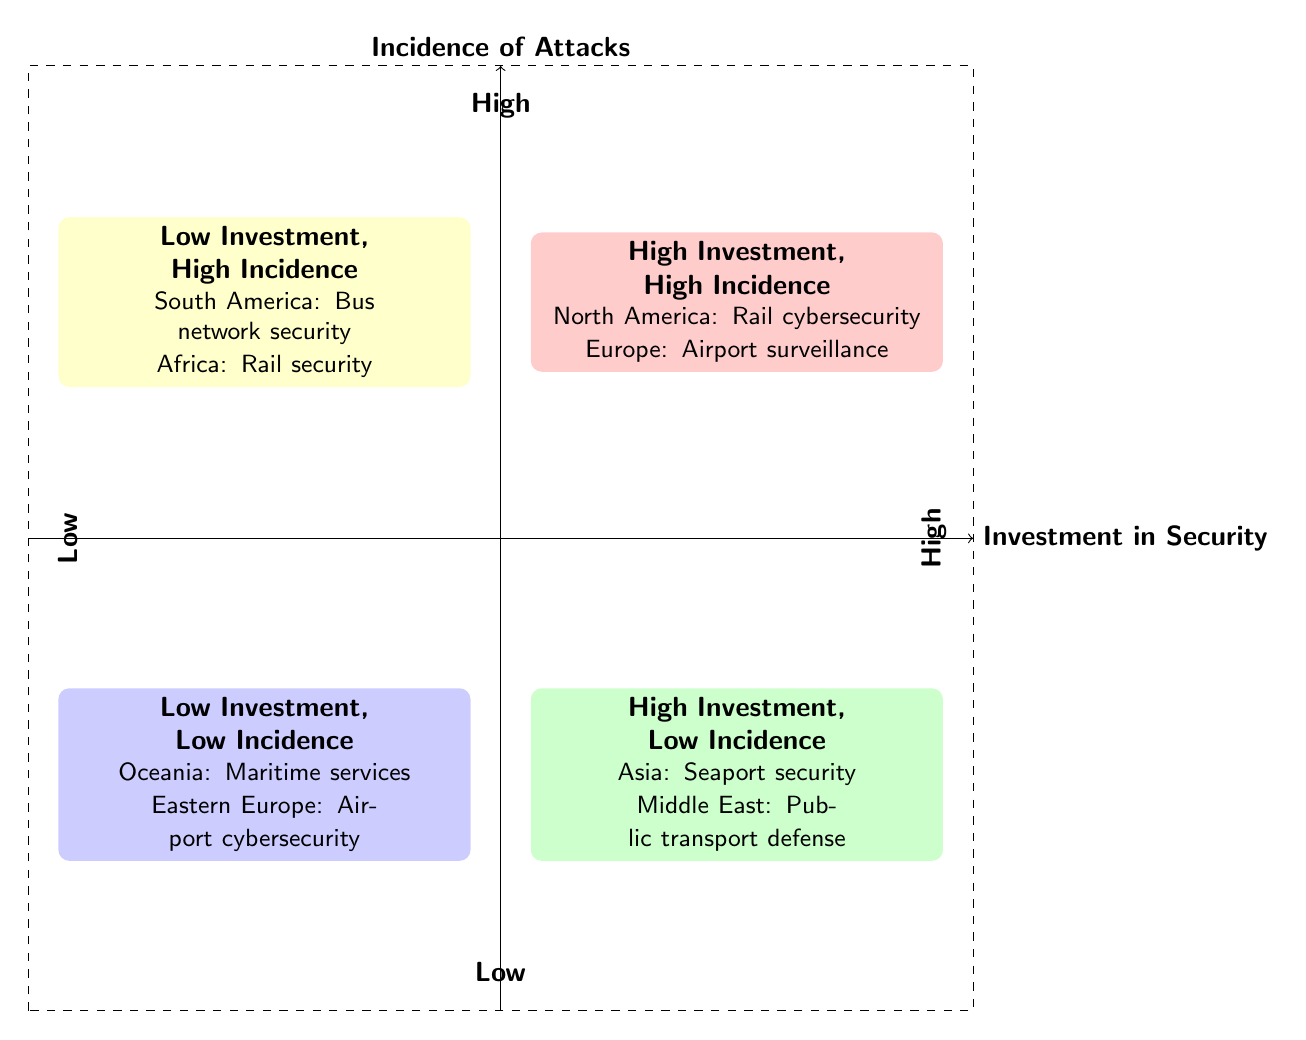What region has high investment and high incidence of attacks? The diagram shows that North America is in Quadrant I, categorized as having high investment and high incidence of attacks due to the inclusion of "Cybersecurity upgrades in rail systems" and "Frequent ransomware attacks on metro networks."
Answer: North America What type of investment is noted for Asia in Quadrant II? In Quadrant II, Asia is labeled with "Integrated security management for seaports," indicating a significant investment in security that corresponds to low incidence of attacks.
Answer: Integrated security management for seaports Which region has minimal investment and a low incidence of attacks? Eastern Europe is positioned in Quadrant IV, described as having "Limited funding for airport cybersecurity" while experiencing "Few cyber attack incidents reported," categorizing it with low investment and low incidence.
Answer: Eastern Europe How many examples are given for high investment, low incidence? In Quadrant II, there are two specific examples provided: Asia and the Middle East, each illustrating their respective investment in security and attack incidence.
Answer: 2 What is the relationship between investment and incidence in South America as shown in the diagram? South America is placed in Quadrant III, indicating a low investment in security, specifically "Basic cybersecurity measures for bus networks," while experiencing a high incidence of attacks, denoted by "High rate of system hacking incidents."
Answer: Low investment, high incidence What are the security investment examples in Quadrant I? Quadrant I lists two examples: "Cybersecurity upgrades in rail systems" for North America and "Advanced surveillance in airports" for Europe, both highlighting high investment amidst high attack incidences.
Answer: Cybersecurity upgrades in rail systems; Advanced surveillance in airports Which quadrant contains the fewest cyber attack incidents reported? Quadrant IV contains examples of low incidence of attacks, specifically noted with "Few cyber attack incidents reported" for Eastern Europe, placing it in the low investment, low incidence category.
Answer: Quadrant IV Which region is identified with high incidence of vandalism and cyber breaches? The diagram specifies Africa in Quadrant III, which details "Minimal investment in rail security" coupled with a "Frequent vandalism and cyber breaches," denoting high incidence of attacks despite low investment in security.
Answer: Africa 